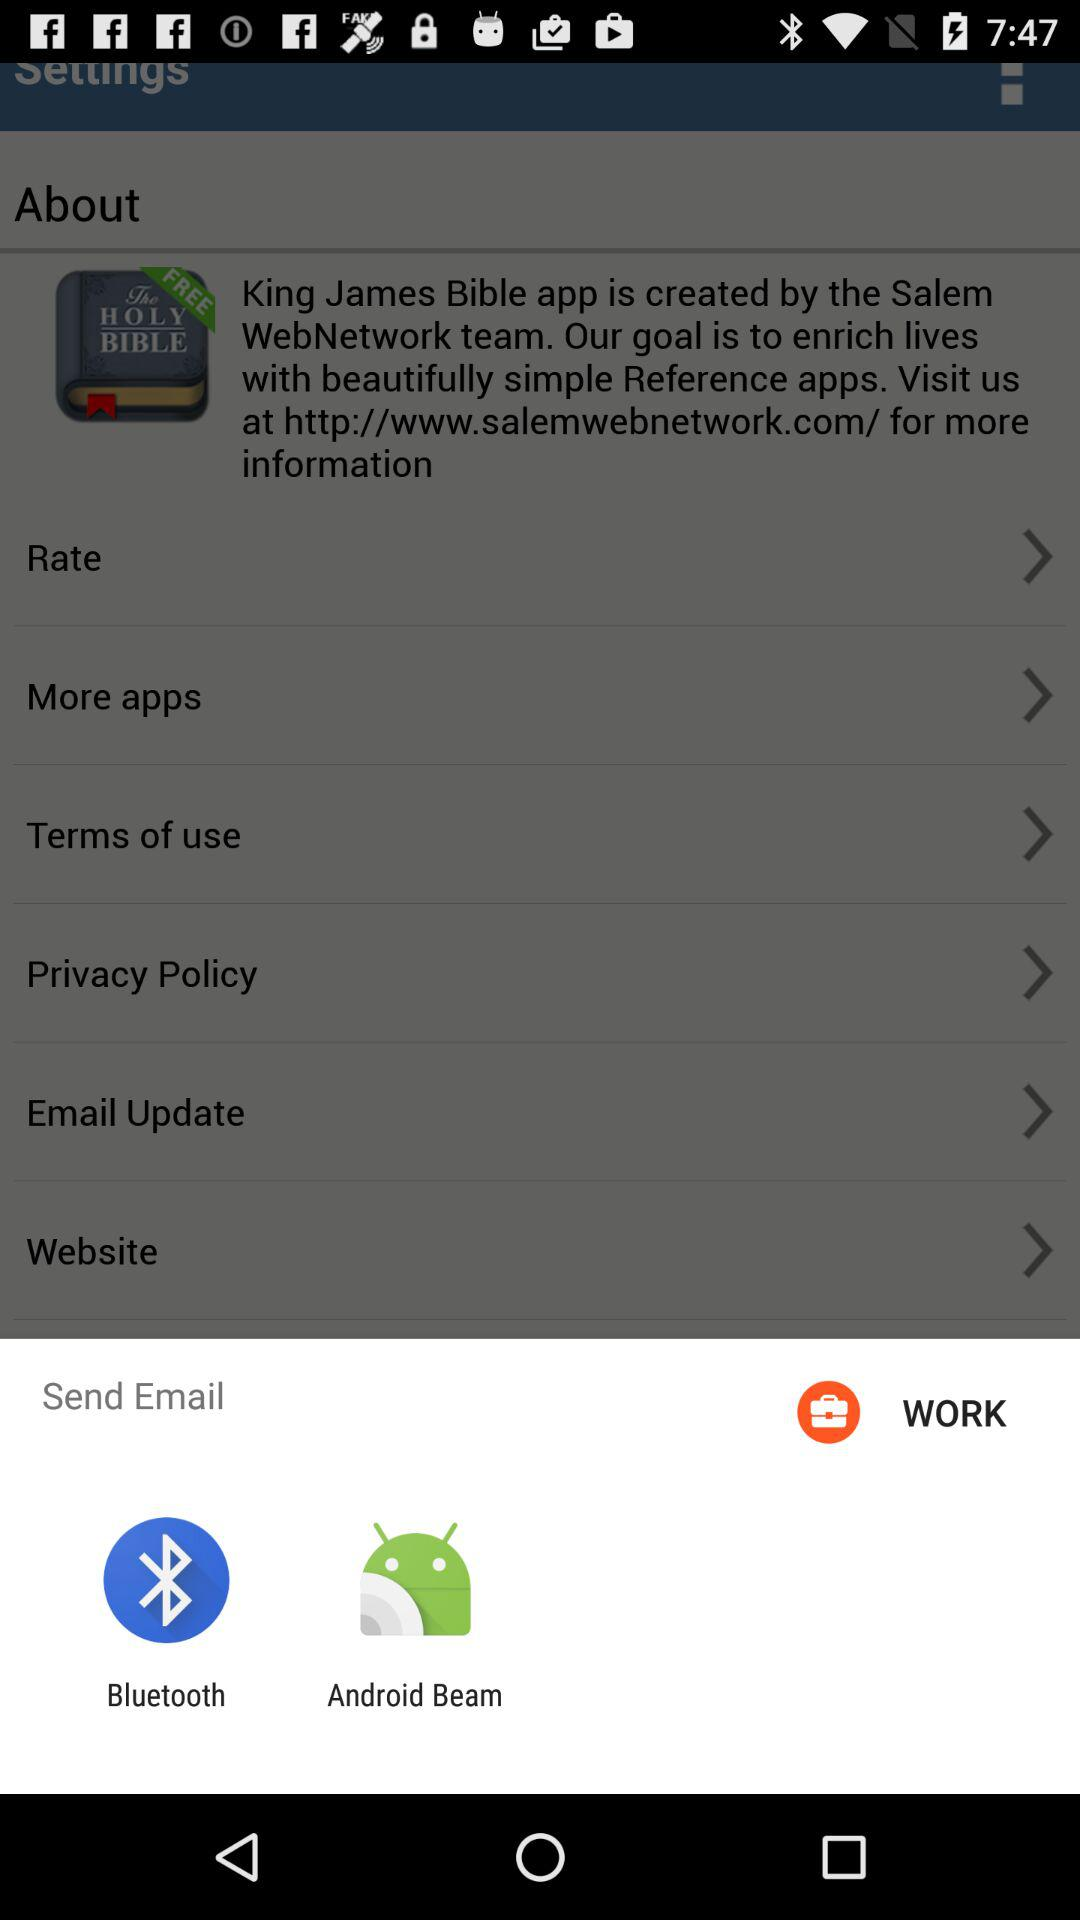Which applications can we use to send email? You can use "Bluetooth" and "Android Beam" to send email. 